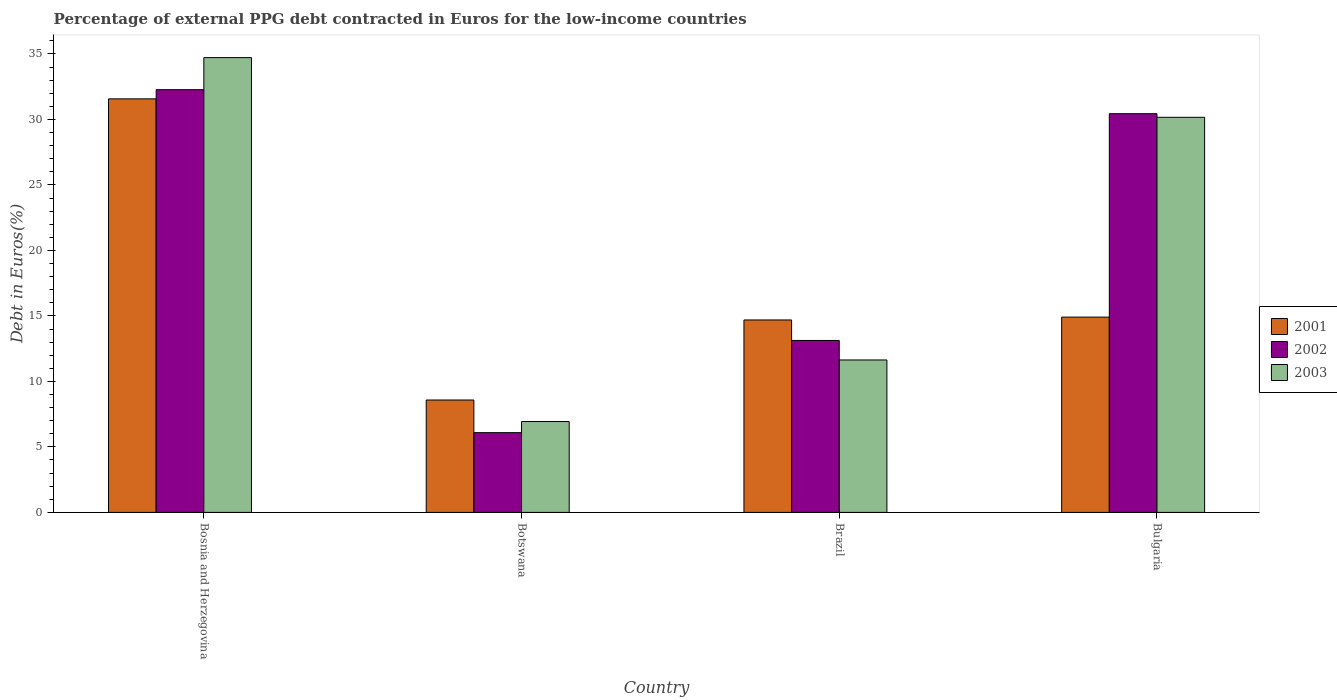How many groups of bars are there?
Keep it short and to the point. 4. Are the number of bars on each tick of the X-axis equal?
Provide a succinct answer. Yes. How many bars are there on the 2nd tick from the left?
Offer a very short reply. 3. How many bars are there on the 3rd tick from the right?
Offer a very short reply. 3. What is the label of the 2nd group of bars from the left?
Ensure brevity in your answer.  Botswana. What is the percentage of external PPG debt contracted in Euros in 2001 in Botswana?
Make the answer very short. 8.58. Across all countries, what is the maximum percentage of external PPG debt contracted in Euros in 2002?
Keep it short and to the point. 32.27. Across all countries, what is the minimum percentage of external PPG debt contracted in Euros in 2003?
Offer a very short reply. 6.94. In which country was the percentage of external PPG debt contracted in Euros in 2003 maximum?
Provide a short and direct response. Bosnia and Herzegovina. In which country was the percentage of external PPG debt contracted in Euros in 2003 minimum?
Keep it short and to the point. Botswana. What is the total percentage of external PPG debt contracted in Euros in 2002 in the graph?
Give a very brief answer. 81.92. What is the difference between the percentage of external PPG debt contracted in Euros in 2003 in Brazil and that in Bulgaria?
Provide a succinct answer. -18.52. What is the difference between the percentage of external PPG debt contracted in Euros in 2003 in Brazil and the percentage of external PPG debt contracted in Euros in 2001 in Bulgaria?
Ensure brevity in your answer.  -3.27. What is the average percentage of external PPG debt contracted in Euros in 2003 per country?
Give a very brief answer. 20.86. What is the difference between the percentage of external PPG debt contracted in Euros of/in 2003 and percentage of external PPG debt contracted in Euros of/in 2001 in Brazil?
Your answer should be compact. -3.05. What is the ratio of the percentage of external PPG debt contracted in Euros in 2001 in Bosnia and Herzegovina to that in Brazil?
Offer a very short reply. 2.15. Is the difference between the percentage of external PPG debt contracted in Euros in 2003 in Bosnia and Herzegovina and Bulgaria greater than the difference between the percentage of external PPG debt contracted in Euros in 2001 in Bosnia and Herzegovina and Bulgaria?
Offer a terse response. No. What is the difference between the highest and the second highest percentage of external PPG debt contracted in Euros in 2001?
Offer a terse response. -0.22. What is the difference between the highest and the lowest percentage of external PPG debt contracted in Euros in 2001?
Your answer should be compact. 22.99. In how many countries, is the percentage of external PPG debt contracted in Euros in 2001 greater than the average percentage of external PPG debt contracted in Euros in 2001 taken over all countries?
Offer a terse response. 1. Is the sum of the percentage of external PPG debt contracted in Euros in 2003 in Bosnia and Herzegovina and Botswana greater than the maximum percentage of external PPG debt contracted in Euros in 2002 across all countries?
Provide a succinct answer. Yes. What does the 2nd bar from the right in Brazil represents?
Your answer should be compact. 2002. Is it the case that in every country, the sum of the percentage of external PPG debt contracted in Euros in 2001 and percentage of external PPG debt contracted in Euros in 2002 is greater than the percentage of external PPG debt contracted in Euros in 2003?
Ensure brevity in your answer.  Yes. Are all the bars in the graph horizontal?
Ensure brevity in your answer.  No. How many countries are there in the graph?
Your answer should be compact. 4. Are the values on the major ticks of Y-axis written in scientific E-notation?
Keep it short and to the point. No. Does the graph contain grids?
Offer a very short reply. No. How many legend labels are there?
Provide a succinct answer. 3. What is the title of the graph?
Give a very brief answer. Percentage of external PPG debt contracted in Euros for the low-income countries. What is the label or title of the Y-axis?
Provide a succinct answer. Debt in Euros(%). What is the Debt in Euros(%) in 2001 in Bosnia and Herzegovina?
Your answer should be compact. 31.57. What is the Debt in Euros(%) of 2002 in Bosnia and Herzegovina?
Provide a succinct answer. 32.27. What is the Debt in Euros(%) of 2003 in Bosnia and Herzegovina?
Provide a short and direct response. 34.72. What is the Debt in Euros(%) of 2001 in Botswana?
Provide a succinct answer. 8.58. What is the Debt in Euros(%) of 2002 in Botswana?
Give a very brief answer. 6.09. What is the Debt in Euros(%) of 2003 in Botswana?
Provide a succinct answer. 6.94. What is the Debt in Euros(%) of 2001 in Brazil?
Keep it short and to the point. 14.69. What is the Debt in Euros(%) of 2002 in Brazil?
Make the answer very short. 13.13. What is the Debt in Euros(%) in 2003 in Brazil?
Your answer should be compact. 11.64. What is the Debt in Euros(%) of 2001 in Bulgaria?
Your response must be concise. 14.91. What is the Debt in Euros(%) of 2002 in Bulgaria?
Provide a short and direct response. 30.44. What is the Debt in Euros(%) in 2003 in Bulgaria?
Offer a terse response. 30.16. Across all countries, what is the maximum Debt in Euros(%) of 2001?
Make the answer very short. 31.57. Across all countries, what is the maximum Debt in Euros(%) of 2002?
Make the answer very short. 32.27. Across all countries, what is the maximum Debt in Euros(%) in 2003?
Offer a terse response. 34.72. Across all countries, what is the minimum Debt in Euros(%) of 2001?
Keep it short and to the point. 8.58. Across all countries, what is the minimum Debt in Euros(%) in 2002?
Give a very brief answer. 6.09. Across all countries, what is the minimum Debt in Euros(%) of 2003?
Offer a terse response. 6.94. What is the total Debt in Euros(%) of 2001 in the graph?
Your response must be concise. 69.74. What is the total Debt in Euros(%) of 2002 in the graph?
Provide a succinct answer. 81.92. What is the total Debt in Euros(%) in 2003 in the graph?
Keep it short and to the point. 83.45. What is the difference between the Debt in Euros(%) in 2001 in Bosnia and Herzegovina and that in Botswana?
Ensure brevity in your answer.  22.99. What is the difference between the Debt in Euros(%) in 2002 in Bosnia and Herzegovina and that in Botswana?
Offer a very short reply. 26.18. What is the difference between the Debt in Euros(%) in 2003 in Bosnia and Herzegovina and that in Botswana?
Offer a terse response. 27.78. What is the difference between the Debt in Euros(%) in 2001 in Bosnia and Herzegovina and that in Brazil?
Offer a very short reply. 16.88. What is the difference between the Debt in Euros(%) in 2002 in Bosnia and Herzegovina and that in Brazil?
Keep it short and to the point. 19.14. What is the difference between the Debt in Euros(%) in 2003 in Bosnia and Herzegovina and that in Brazil?
Provide a short and direct response. 23.08. What is the difference between the Debt in Euros(%) in 2001 in Bosnia and Herzegovina and that in Bulgaria?
Make the answer very short. 16.66. What is the difference between the Debt in Euros(%) in 2002 in Bosnia and Herzegovina and that in Bulgaria?
Give a very brief answer. 1.83. What is the difference between the Debt in Euros(%) in 2003 in Bosnia and Herzegovina and that in Bulgaria?
Make the answer very short. 4.56. What is the difference between the Debt in Euros(%) of 2001 in Botswana and that in Brazil?
Provide a short and direct response. -6.11. What is the difference between the Debt in Euros(%) of 2002 in Botswana and that in Brazil?
Offer a terse response. -7.04. What is the difference between the Debt in Euros(%) of 2003 in Botswana and that in Brazil?
Your answer should be very brief. -4.7. What is the difference between the Debt in Euros(%) in 2001 in Botswana and that in Bulgaria?
Offer a very short reply. -6.33. What is the difference between the Debt in Euros(%) in 2002 in Botswana and that in Bulgaria?
Make the answer very short. -24.35. What is the difference between the Debt in Euros(%) of 2003 in Botswana and that in Bulgaria?
Provide a succinct answer. -23.22. What is the difference between the Debt in Euros(%) in 2001 in Brazil and that in Bulgaria?
Your answer should be very brief. -0.22. What is the difference between the Debt in Euros(%) of 2002 in Brazil and that in Bulgaria?
Keep it short and to the point. -17.31. What is the difference between the Debt in Euros(%) in 2003 in Brazil and that in Bulgaria?
Offer a terse response. -18.52. What is the difference between the Debt in Euros(%) in 2001 in Bosnia and Herzegovina and the Debt in Euros(%) in 2002 in Botswana?
Offer a terse response. 25.48. What is the difference between the Debt in Euros(%) of 2001 in Bosnia and Herzegovina and the Debt in Euros(%) of 2003 in Botswana?
Offer a terse response. 24.63. What is the difference between the Debt in Euros(%) in 2002 in Bosnia and Herzegovina and the Debt in Euros(%) in 2003 in Botswana?
Ensure brevity in your answer.  25.33. What is the difference between the Debt in Euros(%) of 2001 in Bosnia and Herzegovina and the Debt in Euros(%) of 2002 in Brazil?
Provide a succinct answer. 18.44. What is the difference between the Debt in Euros(%) of 2001 in Bosnia and Herzegovina and the Debt in Euros(%) of 2003 in Brazil?
Provide a short and direct response. 19.93. What is the difference between the Debt in Euros(%) of 2002 in Bosnia and Herzegovina and the Debt in Euros(%) of 2003 in Brazil?
Ensure brevity in your answer.  20.63. What is the difference between the Debt in Euros(%) of 2001 in Bosnia and Herzegovina and the Debt in Euros(%) of 2002 in Bulgaria?
Give a very brief answer. 1.13. What is the difference between the Debt in Euros(%) of 2001 in Bosnia and Herzegovina and the Debt in Euros(%) of 2003 in Bulgaria?
Make the answer very short. 1.41. What is the difference between the Debt in Euros(%) of 2002 in Bosnia and Herzegovina and the Debt in Euros(%) of 2003 in Bulgaria?
Your answer should be very brief. 2.11. What is the difference between the Debt in Euros(%) of 2001 in Botswana and the Debt in Euros(%) of 2002 in Brazil?
Make the answer very short. -4.55. What is the difference between the Debt in Euros(%) in 2001 in Botswana and the Debt in Euros(%) in 2003 in Brazil?
Your answer should be compact. -3.06. What is the difference between the Debt in Euros(%) in 2002 in Botswana and the Debt in Euros(%) in 2003 in Brazil?
Your answer should be very brief. -5.55. What is the difference between the Debt in Euros(%) in 2001 in Botswana and the Debt in Euros(%) in 2002 in Bulgaria?
Provide a short and direct response. -21.86. What is the difference between the Debt in Euros(%) in 2001 in Botswana and the Debt in Euros(%) in 2003 in Bulgaria?
Make the answer very short. -21.58. What is the difference between the Debt in Euros(%) of 2002 in Botswana and the Debt in Euros(%) of 2003 in Bulgaria?
Make the answer very short. -24.07. What is the difference between the Debt in Euros(%) in 2001 in Brazil and the Debt in Euros(%) in 2002 in Bulgaria?
Your answer should be compact. -15.75. What is the difference between the Debt in Euros(%) in 2001 in Brazil and the Debt in Euros(%) in 2003 in Bulgaria?
Provide a succinct answer. -15.47. What is the difference between the Debt in Euros(%) in 2002 in Brazil and the Debt in Euros(%) in 2003 in Bulgaria?
Your answer should be very brief. -17.03. What is the average Debt in Euros(%) of 2001 per country?
Your answer should be compact. 17.44. What is the average Debt in Euros(%) of 2002 per country?
Provide a short and direct response. 20.48. What is the average Debt in Euros(%) in 2003 per country?
Ensure brevity in your answer.  20.86. What is the difference between the Debt in Euros(%) in 2001 and Debt in Euros(%) in 2002 in Bosnia and Herzegovina?
Keep it short and to the point. -0.7. What is the difference between the Debt in Euros(%) in 2001 and Debt in Euros(%) in 2003 in Bosnia and Herzegovina?
Provide a succinct answer. -3.15. What is the difference between the Debt in Euros(%) in 2002 and Debt in Euros(%) in 2003 in Bosnia and Herzegovina?
Offer a very short reply. -2.45. What is the difference between the Debt in Euros(%) in 2001 and Debt in Euros(%) in 2002 in Botswana?
Ensure brevity in your answer.  2.49. What is the difference between the Debt in Euros(%) of 2001 and Debt in Euros(%) of 2003 in Botswana?
Your answer should be compact. 1.64. What is the difference between the Debt in Euros(%) in 2002 and Debt in Euros(%) in 2003 in Botswana?
Your answer should be very brief. -0.85. What is the difference between the Debt in Euros(%) in 2001 and Debt in Euros(%) in 2002 in Brazil?
Offer a terse response. 1.56. What is the difference between the Debt in Euros(%) of 2001 and Debt in Euros(%) of 2003 in Brazil?
Offer a very short reply. 3.05. What is the difference between the Debt in Euros(%) in 2002 and Debt in Euros(%) in 2003 in Brazil?
Keep it short and to the point. 1.49. What is the difference between the Debt in Euros(%) in 2001 and Debt in Euros(%) in 2002 in Bulgaria?
Give a very brief answer. -15.53. What is the difference between the Debt in Euros(%) in 2001 and Debt in Euros(%) in 2003 in Bulgaria?
Make the answer very short. -15.25. What is the difference between the Debt in Euros(%) in 2002 and Debt in Euros(%) in 2003 in Bulgaria?
Your response must be concise. 0.28. What is the ratio of the Debt in Euros(%) of 2001 in Bosnia and Herzegovina to that in Botswana?
Offer a very short reply. 3.68. What is the ratio of the Debt in Euros(%) of 2002 in Bosnia and Herzegovina to that in Botswana?
Your answer should be very brief. 5.3. What is the ratio of the Debt in Euros(%) in 2003 in Bosnia and Herzegovina to that in Botswana?
Your answer should be very brief. 5. What is the ratio of the Debt in Euros(%) of 2001 in Bosnia and Herzegovina to that in Brazil?
Keep it short and to the point. 2.15. What is the ratio of the Debt in Euros(%) of 2002 in Bosnia and Herzegovina to that in Brazil?
Offer a very short reply. 2.46. What is the ratio of the Debt in Euros(%) in 2003 in Bosnia and Herzegovina to that in Brazil?
Give a very brief answer. 2.98. What is the ratio of the Debt in Euros(%) in 2001 in Bosnia and Herzegovina to that in Bulgaria?
Your answer should be compact. 2.12. What is the ratio of the Debt in Euros(%) in 2002 in Bosnia and Herzegovina to that in Bulgaria?
Offer a very short reply. 1.06. What is the ratio of the Debt in Euros(%) in 2003 in Bosnia and Herzegovina to that in Bulgaria?
Offer a very short reply. 1.15. What is the ratio of the Debt in Euros(%) in 2001 in Botswana to that in Brazil?
Make the answer very short. 0.58. What is the ratio of the Debt in Euros(%) of 2002 in Botswana to that in Brazil?
Give a very brief answer. 0.46. What is the ratio of the Debt in Euros(%) of 2003 in Botswana to that in Brazil?
Ensure brevity in your answer.  0.6. What is the ratio of the Debt in Euros(%) of 2001 in Botswana to that in Bulgaria?
Keep it short and to the point. 0.58. What is the ratio of the Debt in Euros(%) of 2002 in Botswana to that in Bulgaria?
Give a very brief answer. 0.2. What is the ratio of the Debt in Euros(%) of 2003 in Botswana to that in Bulgaria?
Provide a short and direct response. 0.23. What is the ratio of the Debt in Euros(%) in 2001 in Brazil to that in Bulgaria?
Offer a very short reply. 0.99. What is the ratio of the Debt in Euros(%) in 2002 in Brazil to that in Bulgaria?
Provide a succinct answer. 0.43. What is the ratio of the Debt in Euros(%) in 2003 in Brazil to that in Bulgaria?
Your answer should be very brief. 0.39. What is the difference between the highest and the second highest Debt in Euros(%) of 2001?
Your answer should be compact. 16.66. What is the difference between the highest and the second highest Debt in Euros(%) in 2002?
Make the answer very short. 1.83. What is the difference between the highest and the second highest Debt in Euros(%) in 2003?
Give a very brief answer. 4.56. What is the difference between the highest and the lowest Debt in Euros(%) in 2001?
Your response must be concise. 22.99. What is the difference between the highest and the lowest Debt in Euros(%) of 2002?
Keep it short and to the point. 26.18. What is the difference between the highest and the lowest Debt in Euros(%) in 2003?
Offer a terse response. 27.78. 